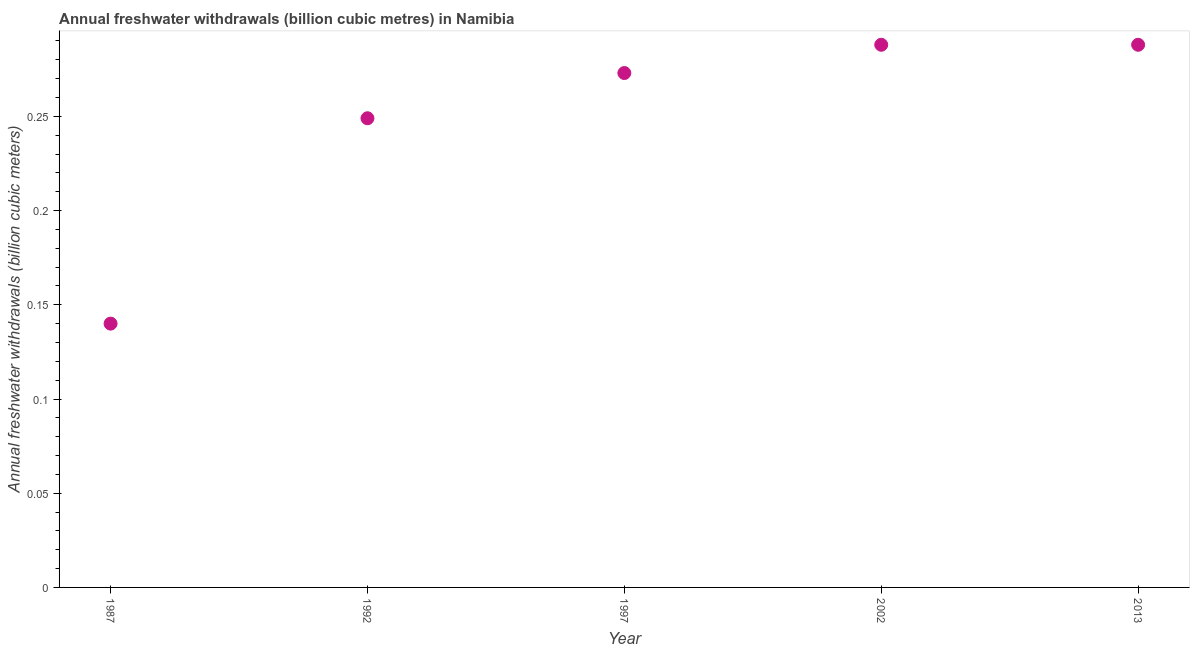What is the annual freshwater withdrawals in 1997?
Provide a short and direct response. 0.27. Across all years, what is the maximum annual freshwater withdrawals?
Provide a short and direct response. 0.29. Across all years, what is the minimum annual freshwater withdrawals?
Your answer should be very brief. 0.14. What is the sum of the annual freshwater withdrawals?
Your response must be concise. 1.24. What is the difference between the annual freshwater withdrawals in 1992 and 2013?
Your answer should be compact. -0.04. What is the average annual freshwater withdrawals per year?
Offer a terse response. 0.25. What is the median annual freshwater withdrawals?
Give a very brief answer. 0.27. What is the ratio of the annual freshwater withdrawals in 1992 to that in 1997?
Provide a succinct answer. 0.91. Is the annual freshwater withdrawals in 1997 less than that in 2013?
Ensure brevity in your answer.  Yes. Is the difference between the annual freshwater withdrawals in 1987 and 2002 greater than the difference between any two years?
Your response must be concise. Yes. What is the difference between the highest and the lowest annual freshwater withdrawals?
Offer a terse response. 0.15. Does the annual freshwater withdrawals monotonically increase over the years?
Your response must be concise. No. How many dotlines are there?
Ensure brevity in your answer.  1. What is the difference between two consecutive major ticks on the Y-axis?
Keep it short and to the point. 0.05. Does the graph contain any zero values?
Keep it short and to the point. No. What is the title of the graph?
Your answer should be very brief. Annual freshwater withdrawals (billion cubic metres) in Namibia. What is the label or title of the X-axis?
Offer a very short reply. Year. What is the label or title of the Y-axis?
Provide a succinct answer. Annual freshwater withdrawals (billion cubic meters). What is the Annual freshwater withdrawals (billion cubic meters) in 1987?
Offer a very short reply. 0.14. What is the Annual freshwater withdrawals (billion cubic meters) in 1992?
Offer a very short reply. 0.25. What is the Annual freshwater withdrawals (billion cubic meters) in 1997?
Your answer should be compact. 0.27. What is the Annual freshwater withdrawals (billion cubic meters) in 2002?
Make the answer very short. 0.29. What is the Annual freshwater withdrawals (billion cubic meters) in 2013?
Give a very brief answer. 0.29. What is the difference between the Annual freshwater withdrawals (billion cubic meters) in 1987 and 1992?
Your response must be concise. -0.11. What is the difference between the Annual freshwater withdrawals (billion cubic meters) in 1987 and 1997?
Ensure brevity in your answer.  -0.13. What is the difference between the Annual freshwater withdrawals (billion cubic meters) in 1987 and 2002?
Keep it short and to the point. -0.15. What is the difference between the Annual freshwater withdrawals (billion cubic meters) in 1987 and 2013?
Offer a very short reply. -0.15. What is the difference between the Annual freshwater withdrawals (billion cubic meters) in 1992 and 1997?
Ensure brevity in your answer.  -0.02. What is the difference between the Annual freshwater withdrawals (billion cubic meters) in 1992 and 2002?
Offer a very short reply. -0.04. What is the difference between the Annual freshwater withdrawals (billion cubic meters) in 1992 and 2013?
Your answer should be compact. -0.04. What is the difference between the Annual freshwater withdrawals (billion cubic meters) in 1997 and 2002?
Offer a terse response. -0.01. What is the difference between the Annual freshwater withdrawals (billion cubic meters) in 1997 and 2013?
Make the answer very short. -0.01. What is the difference between the Annual freshwater withdrawals (billion cubic meters) in 2002 and 2013?
Offer a very short reply. 0. What is the ratio of the Annual freshwater withdrawals (billion cubic meters) in 1987 to that in 1992?
Offer a very short reply. 0.56. What is the ratio of the Annual freshwater withdrawals (billion cubic meters) in 1987 to that in 1997?
Provide a succinct answer. 0.51. What is the ratio of the Annual freshwater withdrawals (billion cubic meters) in 1987 to that in 2002?
Your response must be concise. 0.49. What is the ratio of the Annual freshwater withdrawals (billion cubic meters) in 1987 to that in 2013?
Give a very brief answer. 0.49. What is the ratio of the Annual freshwater withdrawals (billion cubic meters) in 1992 to that in 1997?
Your response must be concise. 0.91. What is the ratio of the Annual freshwater withdrawals (billion cubic meters) in 1992 to that in 2002?
Your answer should be compact. 0.86. What is the ratio of the Annual freshwater withdrawals (billion cubic meters) in 1992 to that in 2013?
Make the answer very short. 0.86. What is the ratio of the Annual freshwater withdrawals (billion cubic meters) in 1997 to that in 2002?
Offer a very short reply. 0.95. What is the ratio of the Annual freshwater withdrawals (billion cubic meters) in 1997 to that in 2013?
Ensure brevity in your answer.  0.95. 